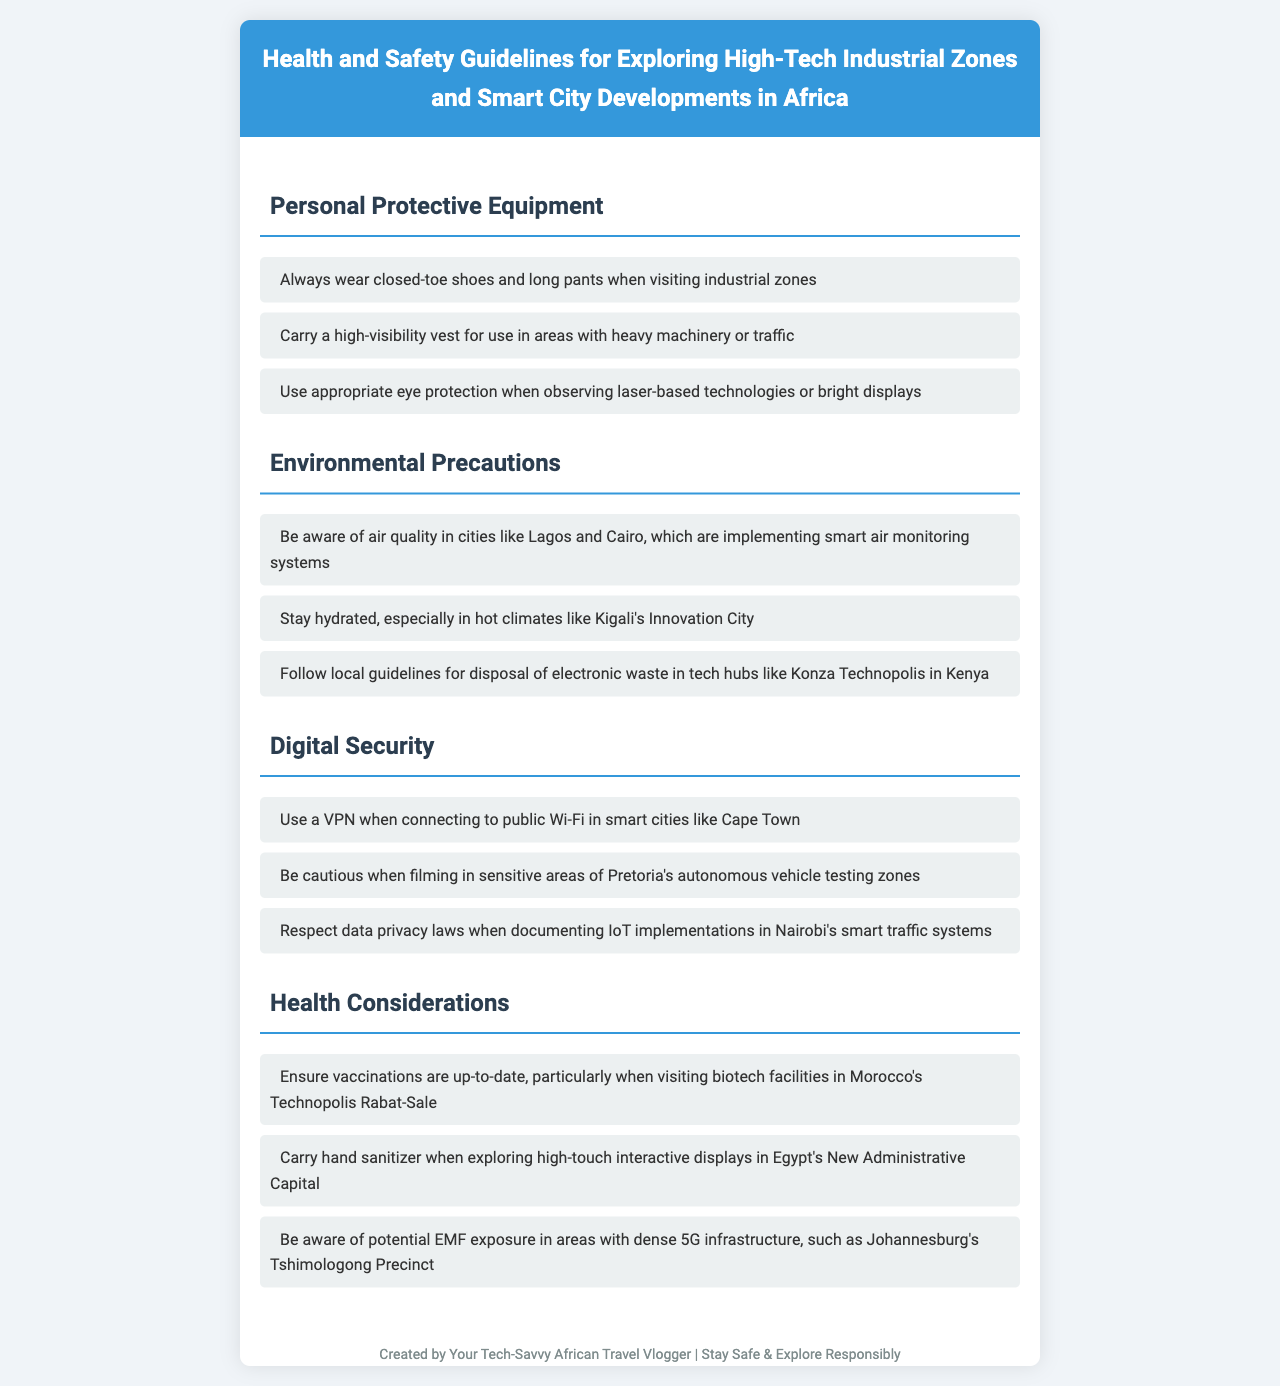What should you always wear when visiting industrial zones? The document mentions that one should always wear closed-toe shoes and long pants when visiting industrial zones.
Answer: Closed-toe shoes and long pants Which city is implementing smart air monitoring systems? The document states that cities like Lagos and Cairo are implementing smart air monitoring systems.
Answer: Lagos and Cairo What should you carry when exploring high-touch interactive displays? The guidelines recommend carrying hand sanitizer when exploring high-touch interactive displays.
Answer: Hand sanitizer What safety equipment is advised for areas with heavy machinery? A high-visibility vest is advised for use in areas with heavy machinery or traffic.
Answer: High-visibility vest What is a precaution when connecting to public Wi-Fi in smart cities? The document advises using a VPN when connecting to public Wi-Fi in smart cities like Cape Town.
Answer: Use a VPN Which city's innovation hub requires hydration awareness? The document mentions that one should stay hydrated, especially in hot climates like Kigali's Innovation City.
Answer: Kigali's Innovation City When documenting IoT implementations, what should you respect? The guidelines state that one should respect data privacy laws when documenting IoT implementations.
Answer: Data privacy laws What health consideration is emphasized for biotech facility visits in Morocco? The document emphasizes ensuring vaccinations are up-to-date, particularly when visiting biotech facilities in Morocco.
Answer: Vaccinations up-to-date In which development should one be aware of potential EMF exposure? The guidelines highlight being aware of potential EMF exposure in areas with dense 5G infrastructure, such as Johannesburg's Tshimologong Precinct.
Answer: Johannesburg's Tshimologong Precinct 